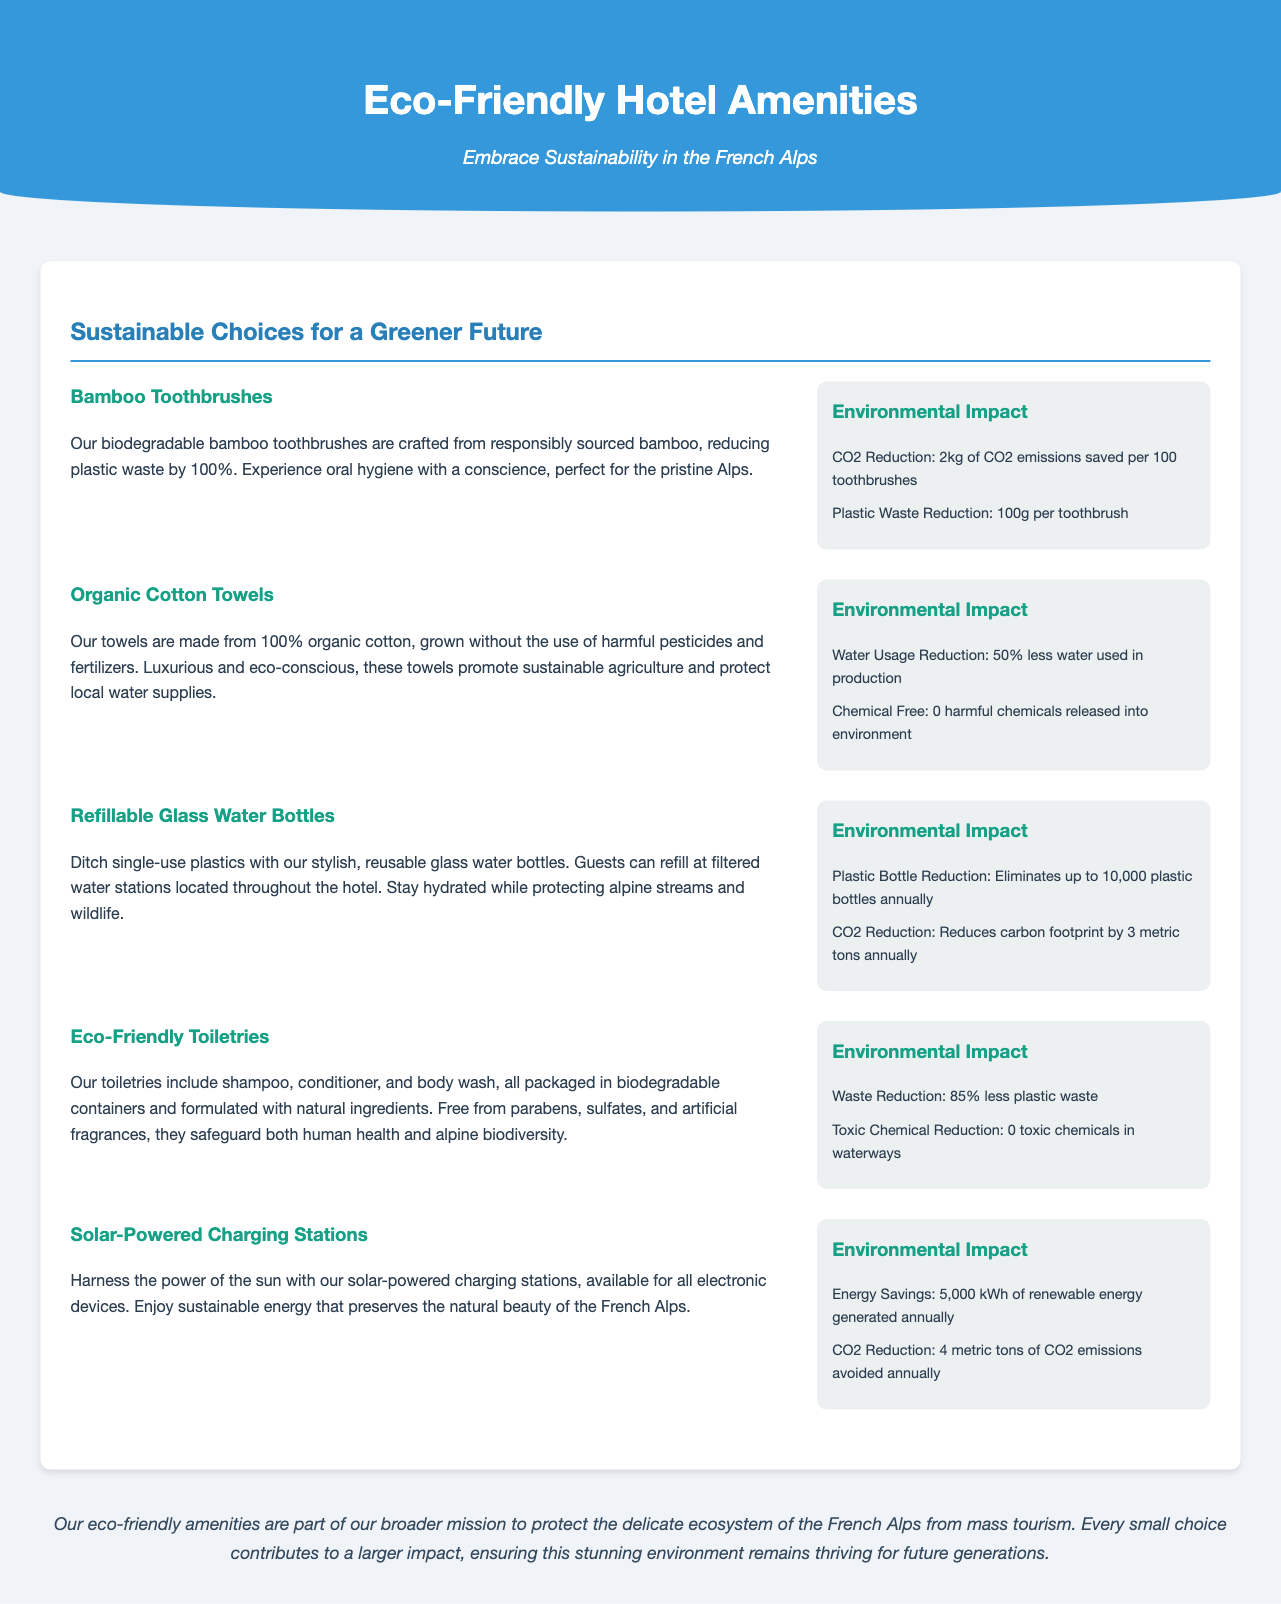what is the first product listed? The first product listed in the document is "Bamboo Toothbrushes."
Answer: Bamboo Toothbrushes how much CO2 is saved per 100 toothbrushes? The document states that 2kg of CO2 emissions are saved per 100 toothbrushes.
Answer: 2kg what percentage water reduction is achieved with organic cotton towels? The document mentions that there is a 50% less water used in the production of organic cotton towels.
Answer: 50% how many plastic bottles are eliminated annually with refillable glass water bottles? According to the document, refillable glass water bottles eliminate up to 10,000 plastic bottles annually.
Answer: 10,000 what is the environmental impact of solar-powered charging stations? The solar-powered charging stations avoid 4 metric tons of CO2 emissions annually, as stated in the document.
Answer: 4 metric tons what community goal do the eco-friendly amenities support? The goal articulated in the document is to protect the delicate ecosystem of the French Alps from mass tourism.
Answer: Protecting the delicate ecosystem how are the eco-friendly toiletries packaged? The eco-friendly toiletries are packaged in biodegradable containers, as noted in the document.
Answer: Biodegradable containers how much renewable energy is generated by solar-powered charging stations? The document states that solar-powered charging stations generate 5,000 kWh of renewable energy annually.
Answer: 5,000 kWh 